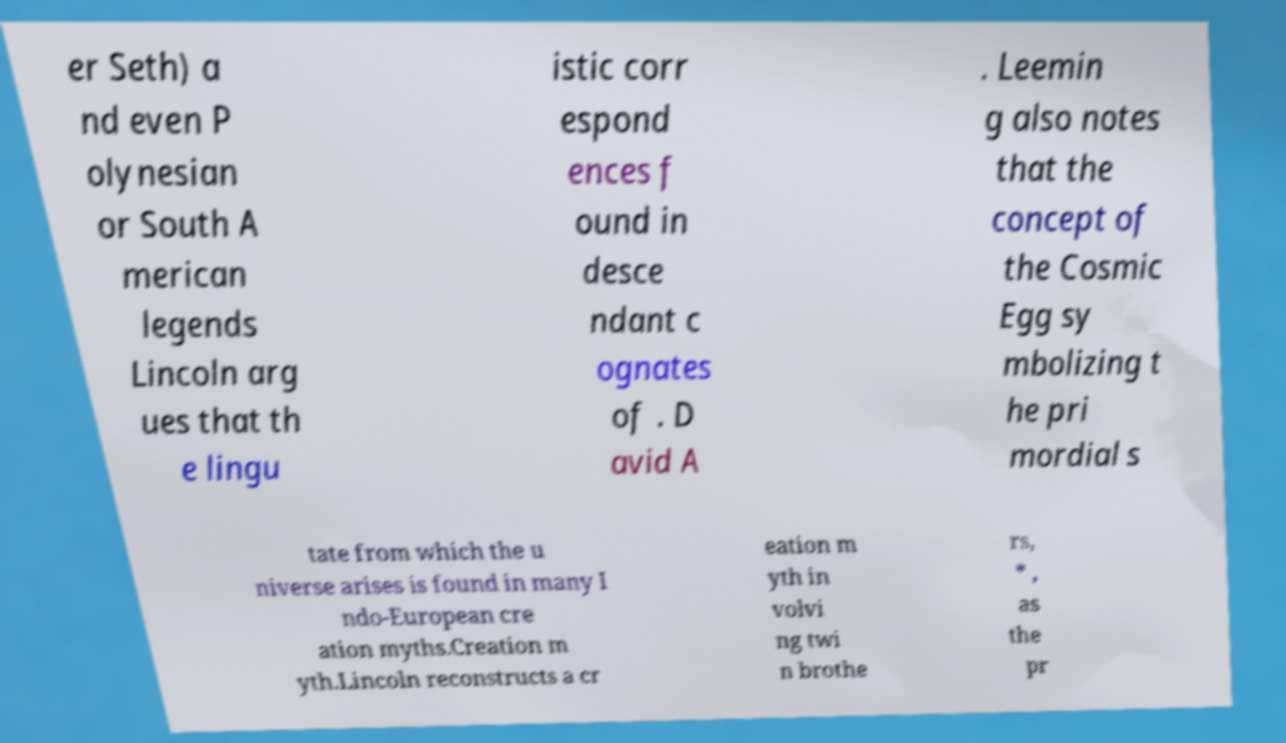Can you read and provide the text displayed in the image?This photo seems to have some interesting text. Can you extract and type it out for me? er Seth) a nd even P olynesian or South A merican legends Lincoln arg ues that th e lingu istic corr espond ences f ound in desce ndant c ognates of . D avid A . Leemin g also notes that the concept of the Cosmic Egg sy mbolizing t he pri mordial s tate from which the u niverse arises is found in many I ndo-European cre ation myths.Creation m yth.Lincoln reconstructs a cr eation m yth in volvi ng twi n brothe rs, * , as the pr 